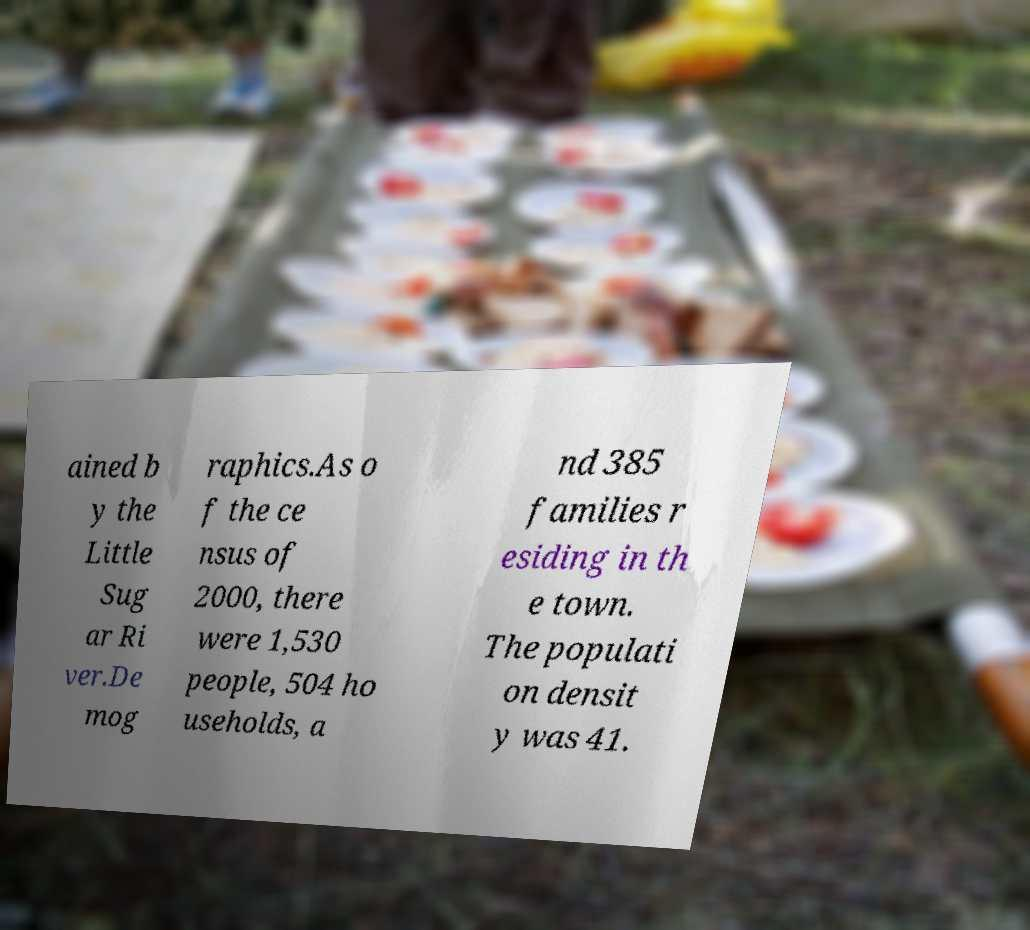Could you extract and type out the text from this image? ained b y the Little Sug ar Ri ver.De mog raphics.As o f the ce nsus of 2000, there were 1,530 people, 504 ho useholds, a nd 385 families r esiding in th e town. The populati on densit y was 41. 